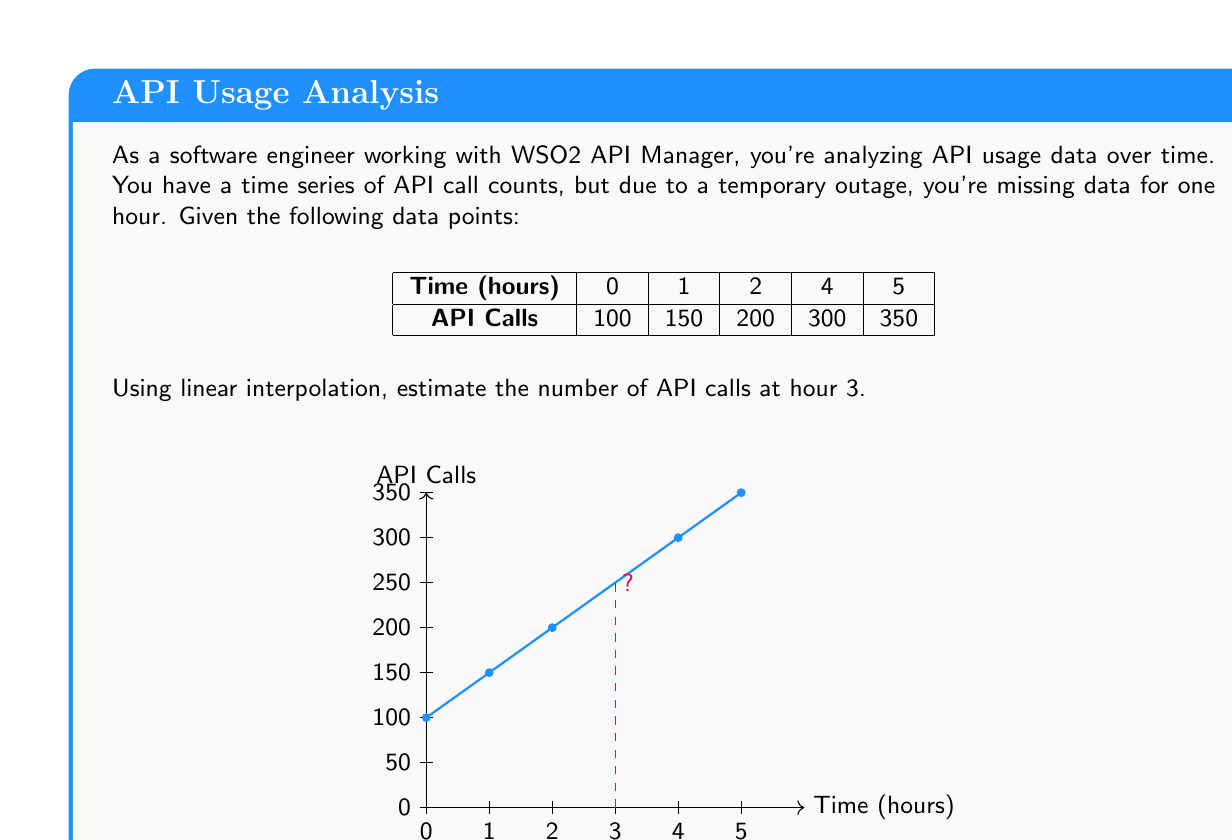Help me with this question. To solve this problem using linear interpolation, we'll follow these steps:

1) Identify the two known points surrounding our target time (hour 3):
   $$(x_1, y_1) = (2, 200)$$ and $$(x_2, y_2) = (4, 300)$$

2) The linear interpolation formula is:
   $$y = y_1 + \frac{(x - x_1)(y_2 - y_1)}{(x_2 - x_1)}$$

   Where $x$ is our target time (3 hours), and $y$ is the value we're solving for.

3) Plug in the values:
   $$y = 200 + \frac{(3 - 2)(300 - 200)}{(4 - 2)}$$

4) Simplify:
   $$y = 200 + \frac{(1)(100)}{(2)}$$
   $$y = 200 + 50$$
   $$y = 250$$

Therefore, the estimated number of API calls at hour 3 is 250.
Answer: 250 API calls 